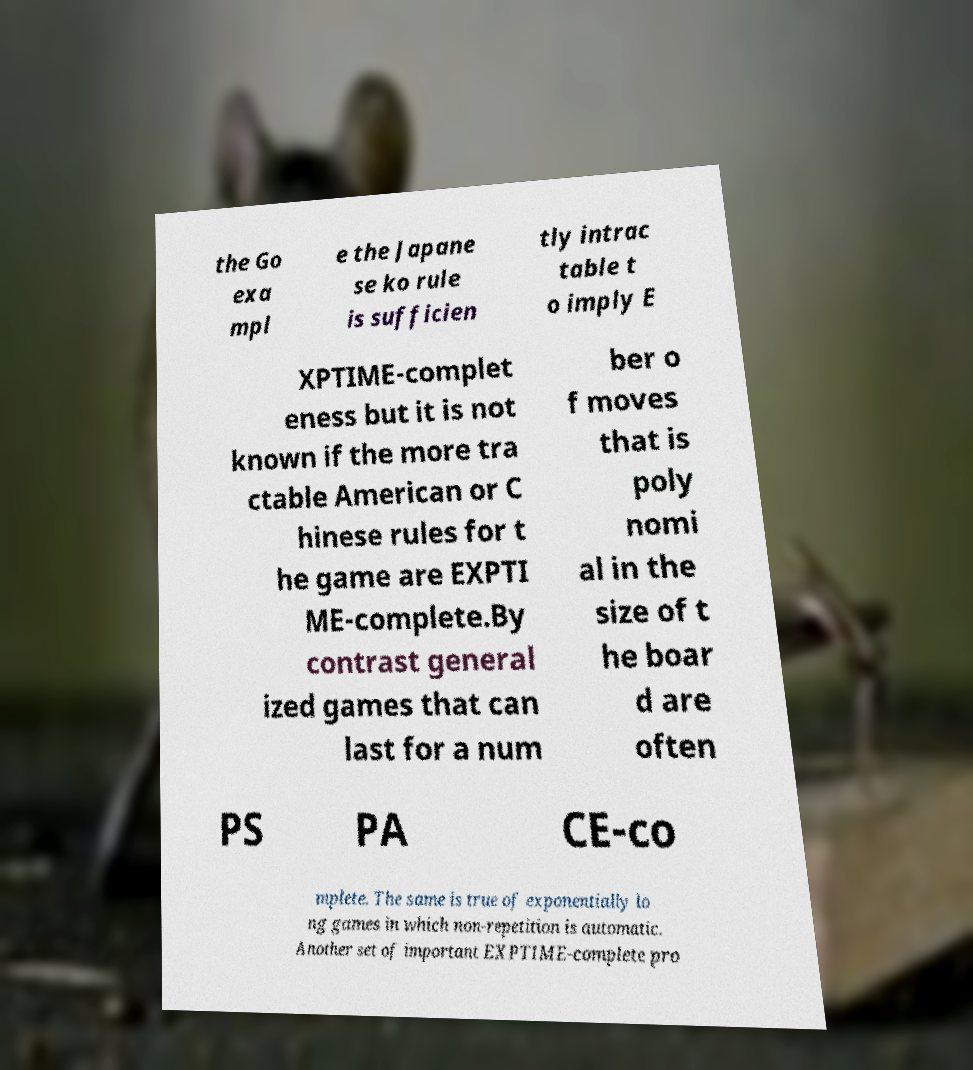What messages or text are displayed in this image? I need them in a readable, typed format. the Go exa mpl e the Japane se ko rule is sufficien tly intrac table t o imply E XPTIME-complet eness but it is not known if the more tra ctable American or C hinese rules for t he game are EXPTI ME-complete.By contrast general ized games that can last for a num ber o f moves that is poly nomi al in the size of t he boar d are often PS PA CE-co mplete. The same is true of exponentially lo ng games in which non-repetition is automatic. Another set of important EXPTIME-complete pro 